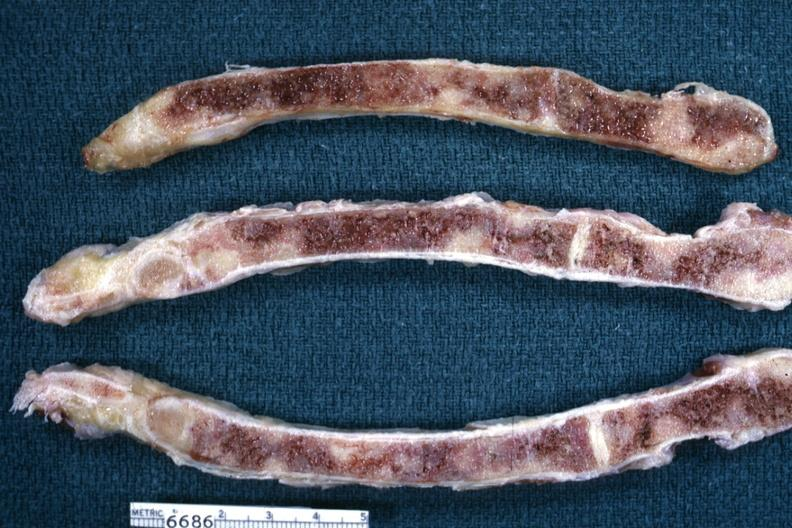s carinal nodes shown close-up nodes present?
Answer the question using a single word or phrase. No 